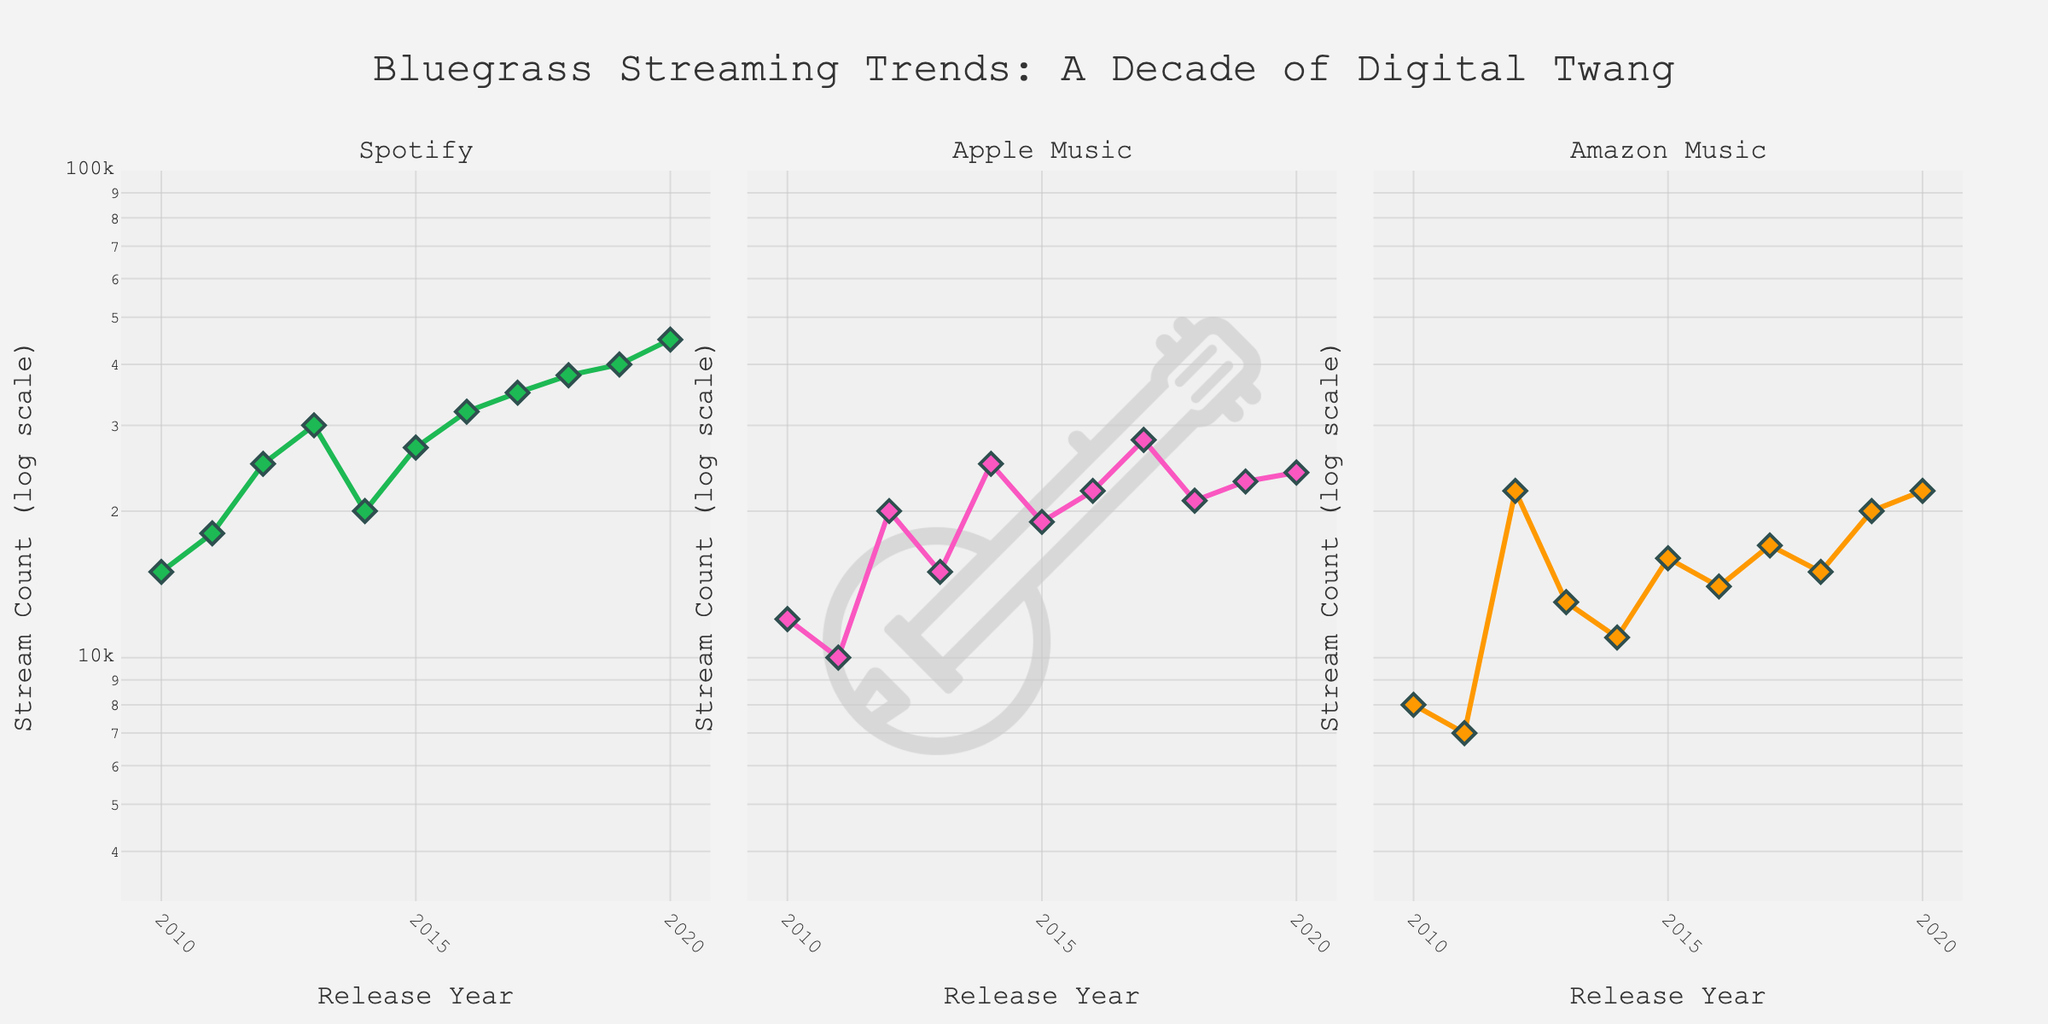What is the title of the figure? The title is located at the top center of the figure and describes the overall theme. It reads "Bluegrass Streaming Trends: A Decade of Digital Twang".
Answer: "Bluegrass Streaming Trends: A Decade of Digital Twang" What years are covered in the figure? The x-axes across the subplots show the release years ranging from 2010 to 2020.
Answer: 2010 to 2020 How many platforms are included in the figure? The subplot titles indicate the number of platforms. There are three: Spotify, Apple Music, and Amazon Music.
Answer: 3 Which song has the highest stream count on Spotify in 2020? On the Spotify subplot, the highest stream count in 2020 is marked at 45,000 streams. The hover text shows this is "If I Could Only Win Your Love".
Answer: If I Could Only Win Your Love Which platform has the overall highest streaming count in 2017? On examining 2017 across all subplots, Spotify shows the highest stream count for "Dueling Banjos" at 35,000.
Answer: Spotify What is the stream count range for the plot, given the log scale? The y-axes range from around 3.5 to 5 on the log scale. This translates to approximately 3,162 (10^3.5) to 100,000 (10^5) streams.
Answer: Approximately 3,162 to 100,000 streams Compare the streaming trends of Spotify and Apple Music in 2016. In 2016, Spotify has a song with 32,000 streams (Earl's Breakdown), and Apple Music has a song with 22,000 streams (Foggy Mountain Breakdown). Spotify has higher streams in 2016.
Answer: Spotify has higher streams than Apple Music What is the average stream count for Amazon Music in 2012 and 2013? For Amazon Music in 2012 and 2013, the stream counts are 22,000 and 13,000 respectively. The average is (22,000 + 13,000) / 2 = 17,500.
Answer: 17,500 How does the size and color of markers help in interpreting the data points for each platform? The size and color of markers (green for Spotify, pink for Apple Music, orange for Amazon Music) help distinguish between platforms, while larger markers and darker borders indicate higher stream counts and platform differentiation.
Answer: Helps in differentiating platforms and highlighting higher streams Which platform saw the steepest increase in streaming counts between 2017 and 2020? Comparing slopes from 2017 to 2020 in each subplot, Spotify's increase from 35,000 (2017) to 45,000 (2020) seems steeper than the increases in Apple Music or Amazon Music.
Answer: Spotify 